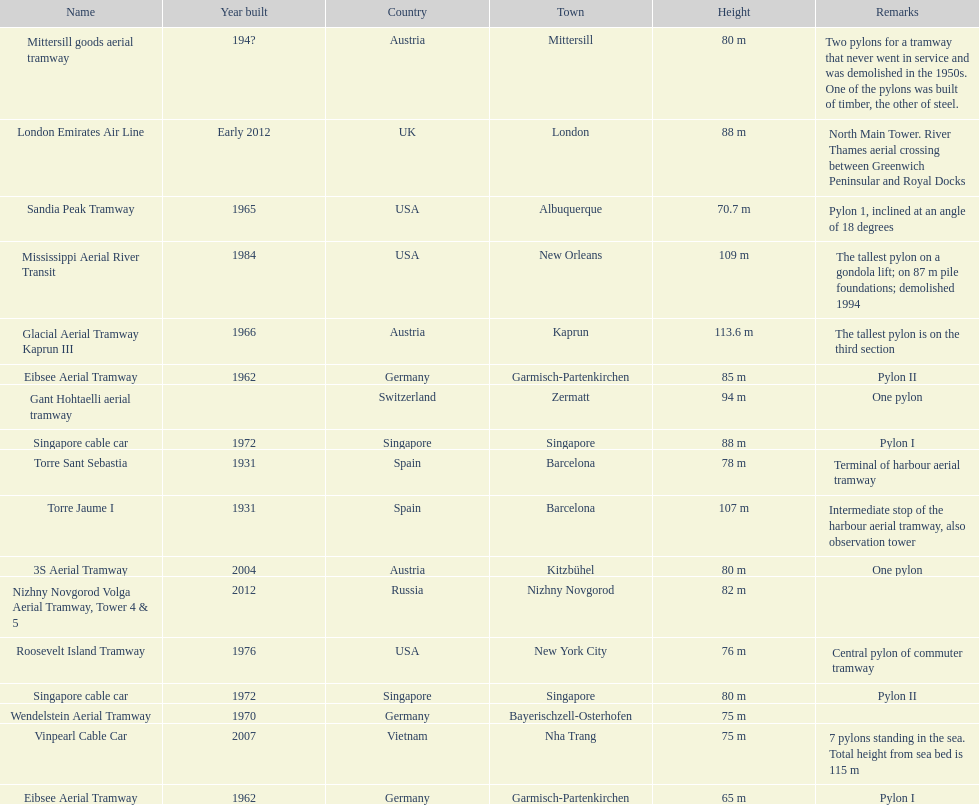How many pylons are in austria? 3. 